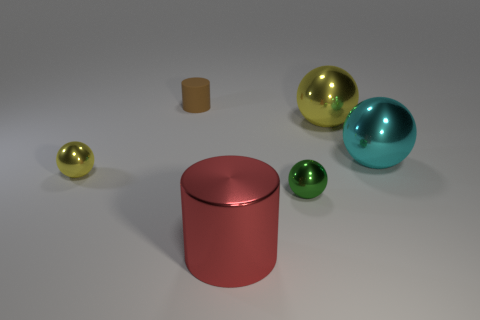What could be the size comparison between the objects? Based on the perspective provided, the sizes of the objects seem to vary. The large cyan metallic ball is the most prominent object, followed by the gold sphere. The green sphere and the cylinder below it are smaller but approximately similar in size, while the tiny cube is the smallest of all the objects. However, without specific measurements or context, exact size comparisons are speculative. 